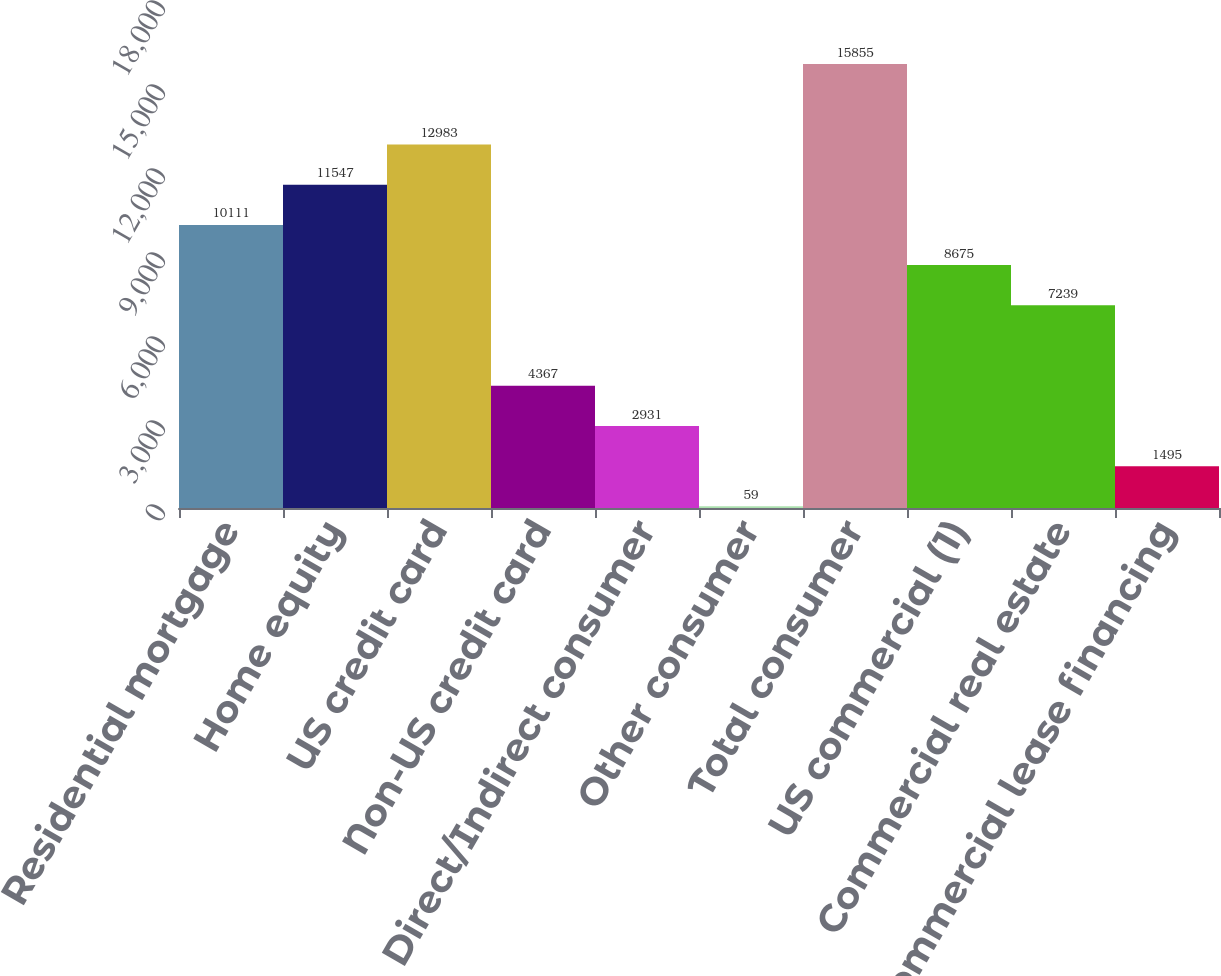Convert chart to OTSL. <chart><loc_0><loc_0><loc_500><loc_500><bar_chart><fcel>Residential mortgage<fcel>Home equity<fcel>US credit card<fcel>Non-US credit card<fcel>Direct/Indirect consumer<fcel>Other consumer<fcel>Total consumer<fcel>US commercial (1)<fcel>Commercial real estate<fcel>Commercial lease financing<nl><fcel>10111<fcel>11547<fcel>12983<fcel>4367<fcel>2931<fcel>59<fcel>15855<fcel>8675<fcel>7239<fcel>1495<nl></chart> 